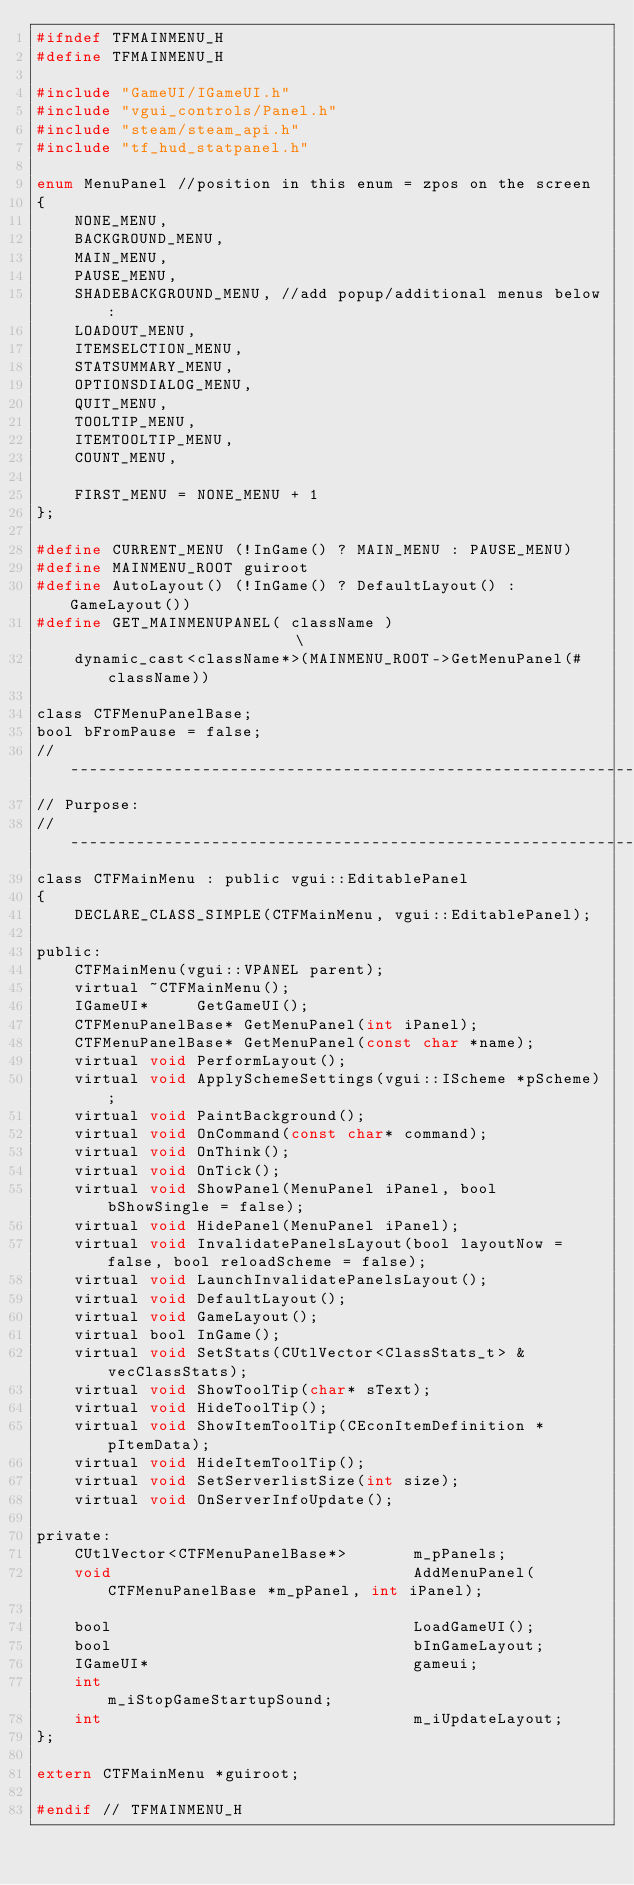<code> <loc_0><loc_0><loc_500><loc_500><_C_>#ifndef TFMAINMENU_H
#define TFMAINMENU_H

#include "GameUI/IGameUI.h"
#include "vgui_controls/Panel.h"
#include "steam/steam_api.h"
#include "tf_hud_statpanel.h"

enum MenuPanel //position in this enum = zpos on the screen
{
	NONE_MENU,
	BACKGROUND_MENU,
	MAIN_MENU,
	PAUSE_MENU,
	SHADEBACKGROUND_MENU, //add popup/additional menus below:		
	LOADOUT_MENU,
	ITEMSELCTION_MENU,
	STATSUMMARY_MENU,
	OPTIONSDIALOG_MENU,
	QUIT_MENU,
	TOOLTIP_MENU,
	ITEMTOOLTIP_MENU,
	COUNT_MENU,

	FIRST_MENU = NONE_MENU + 1
};

#define CURRENT_MENU (!InGame() ? MAIN_MENU : PAUSE_MENU)
#define MAINMENU_ROOT guiroot
#define AutoLayout() (!InGame() ? DefaultLayout() : GameLayout())
#define GET_MAINMENUPANEL( className )												\
	dynamic_cast<className*>(MAINMENU_ROOT->GetMenuPanel(#className))

class CTFMenuPanelBase;
bool bFromPause = false;
//-----------------------------------------------------------------------------
// Purpose: 
//-----------------------------------------------------------------------------
class CTFMainMenu : public vgui::EditablePanel
{
	DECLARE_CLASS_SIMPLE(CTFMainMenu, vgui::EditablePanel);

public:
	CTFMainMenu(vgui::VPANEL parent);
	virtual ~CTFMainMenu();
	IGameUI*	 GetGameUI();
	CTFMenuPanelBase* GetMenuPanel(int iPanel);
	CTFMenuPanelBase* GetMenuPanel(const char *name);	
	virtual void PerformLayout();
	virtual void ApplySchemeSettings(vgui::IScheme *pScheme);
	virtual void PaintBackground();
	virtual void OnCommand(const char* command);
	virtual void OnThink();
	virtual void OnTick();
	virtual void ShowPanel(MenuPanel iPanel, bool bShowSingle = false);
	virtual void HidePanel(MenuPanel iPanel);
	virtual void InvalidatePanelsLayout(bool layoutNow = false, bool reloadScheme = false);
	virtual void LaunchInvalidatePanelsLayout();
	virtual void DefaultLayout();
	virtual void GameLayout();
	virtual bool InGame();
	virtual void SetStats(CUtlVector<ClassStats_t> &vecClassStats);
	virtual void ShowToolTip(char* sText);
	virtual void HideToolTip();
	virtual void ShowItemToolTip(CEconItemDefinition *pItemData);
	virtual void HideItemToolTip();
	virtual void SetServerlistSize(int size);
	virtual void OnServerInfoUpdate();

private:
	CUtlVector<CTFMenuPanelBase*>		m_pPanels;
	void								AddMenuPanel(CTFMenuPanelBase *m_pPanel, int iPanel);

	bool								LoadGameUI();
	bool								bInGameLayout;
	IGameUI*							gameui;
	int									m_iStopGameStartupSound;
	int									m_iUpdateLayout;
};

extern CTFMainMenu *guiroot;

#endif // TFMAINMENU_H</code> 